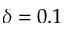Convert formula to latex. <formula><loc_0><loc_0><loc_500><loc_500>\delta = 0 . 1</formula> 